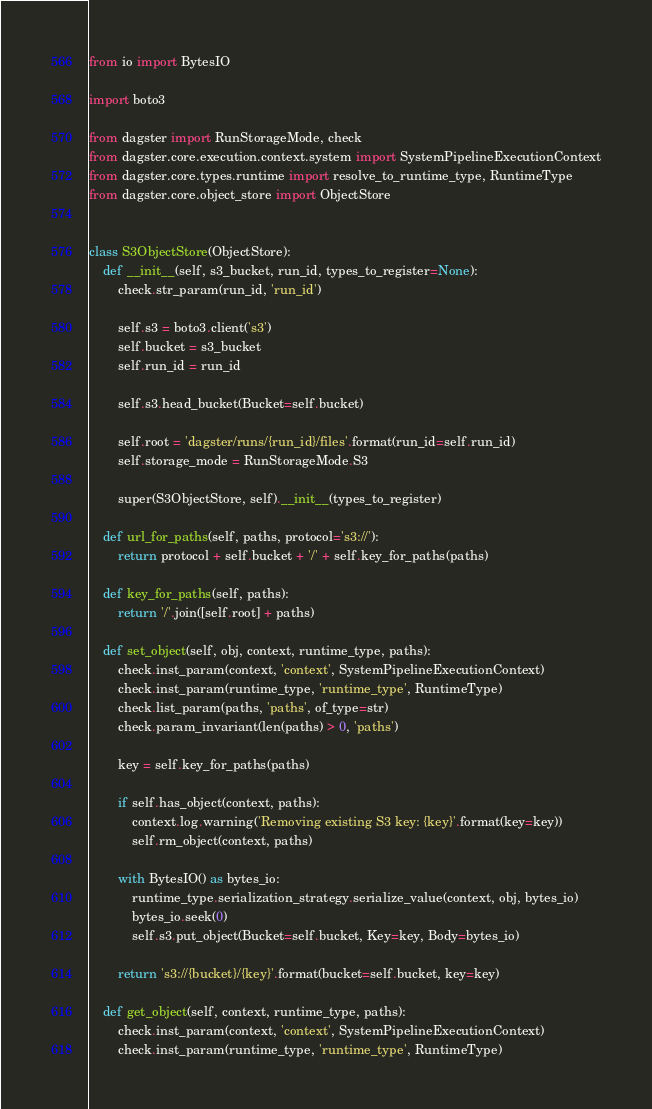Convert code to text. <code><loc_0><loc_0><loc_500><loc_500><_Python_>from io import BytesIO

import boto3

from dagster import RunStorageMode, check
from dagster.core.execution.context.system import SystemPipelineExecutionContext
from dagster.core.types.runtime import resolve_to_runtime_type, RuntimeType
from dagster.core.object_store import ObjectStore


class S3ObjectStore(ObjectStore):
    def __init__(self, s3_bucket, run_id, types_to_register=None):
        check.str_param(run_id, 'run_id')

        self.s3 = boto3.client('s3')
        self.bucket = s3_bucket
        self.run_id = run_id

        self.s3.head_bucket(Bucket=self.bucket)

        self.root = 'dagster/runs/{run_id}/files'.format(run_id=self.run_id)
        self.storage_mode = RunStorageMode.S3

        super(S3ObjectStore, self).__init__(types_to_register)

    def url_for_paths(self, paths, protocol='s3://'):
        return protocol + self.bucket + '/' + self.key_for_paths(paths)

    def key_for_paths(self, paths):
        return '/'.join([self.root] + paths)

    def set_object(self, obj, context, runtime_type, paths):
        check.inst_param(context, 'context', SystemPipelineExecutionContext)
        check.inst_param(runtime_type, 'runtime_type', RuntimeType)
        check.list_param(paths, 'paths', of_type=str)
        check.param_invariant(len(paths) > 0, 'paths')

        key = self.key_for_paths(paths)

        if self.has_object(context, paths):
            context.log.warning('Removing existing S3 key: {key}'.format(key=key))
            self.rm_object(context, paths)

        with BytesIO() as bytes_io:
            runtime_type.serialization_strategy.serialize_value(context, obj, bytes_io)
            bytes_io.seek(0)
            self.s3.put_object(Bucket=self.bucket, Key=key, Body=bytes_io)

        return 's3://{bucket}/{key}'.format(bucket=self.bucket, key=key)

    def get_object(self, context, runtime_type, paths):
        check.inst_param(context, 'context', SystemPipelineExecutionContext)
        check.inst_param(runtime_type, 'runtime_type', RuntimeType)</code> 